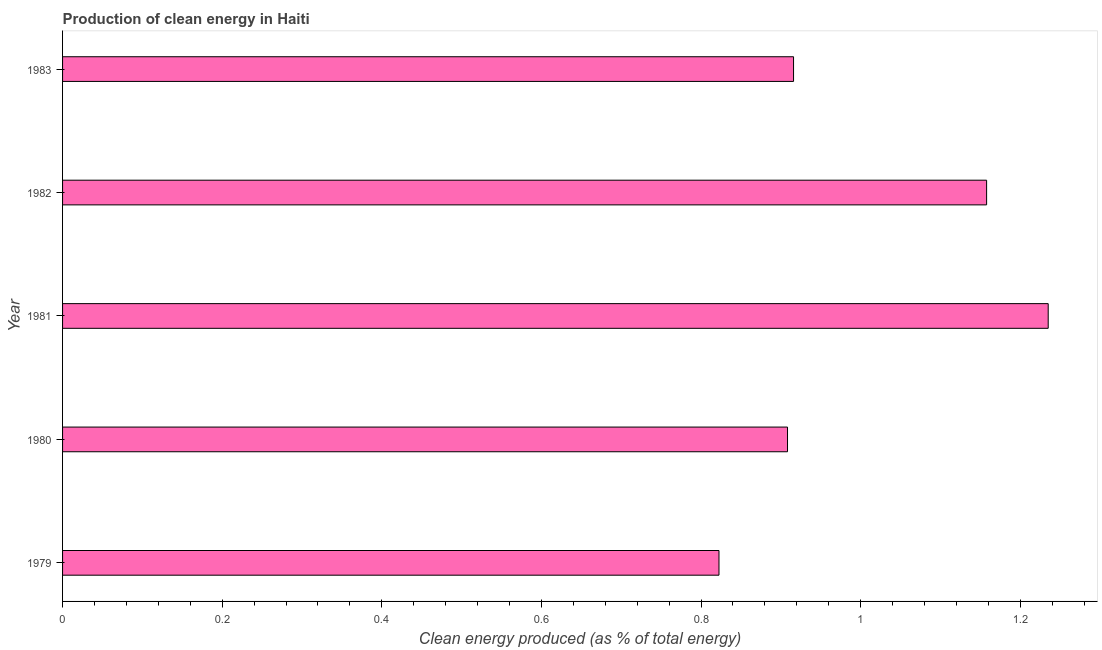What is the title of the graph?
Offer a very short reply. Production of clean energy in Haiti. What is the label or title of the X-axis?
Make the answer very short. Clean energy produced (as % of total energy). What is the production of clean energy in 1983?
Ensure brevity in your answer.  0.92. Across all years, what is the maximum production of clean energy?
Your answer should be compact. 1.23. Across all years, what is the minimum production of clean energy?
Ensure brevity in your answer.  0.82. In which year was the production of clean energy maximum?
Give a very brief answer. 1981. In which year was the production of clean energy minimum?
Provide a succinct answer. 1979. What is the sum of the production of clean energy?
Offer a terse response. 5.04. What is the difference between the production of clean energy in 1981 and 1983?
Your answer should be compact. 0.32. What is the average production of clean energy per year?
Your answer should be compact. 1.01. What is the median production of clean energy?
Offer a very short reply. 0.92. In how many years, is the production of clean energy greater than 0.88 %?
Your response must be concise. 4. What is the ratio of the production of clean energy in 1981 to that in 1982?
Provide a short and direct response. 1.07. Is the difference between the production of clean energy in 1981 and 1982 greater than the difference between any two years?
Keep it short and to the point. No. What is the difference between the highest and the second highest production of clean energy?
Your response must be concise. 0.08. What is the difference between the highest and the lowest production of clean energy?
Your answer should be compact. 0.41. How many bars are there?
Ensure brevity in your answer.  5. How many years are there in the graph?
Offer a terse response. 5. Are the values on the major ticks of X-axis written in scientific E-notation?
Your answer should be compact. No. What is the Clean energy produced (as % of total energy) in 1979?
Provide a short and direct response. 0.82. What is the Clean energy produced (as % of total energy) of 1980?
Your response must be concise. 0.91. What is the Clean energy produced (as % of total energy) in 1981?
Make the answer very short. 1.23. What is the Clean energy produced (as % of total energy) of 1982?
Give a very brief answer. 1.16. What is the Clean energy produced (as % of total energy) in 1983?
Your answer should be compact. 0.92. What is the difference between the Clean energy produced (as % of total energy) in 1979 and 1980?
Provide a short and direct response. -0.09. What is the difference between the Clean energy produced (as % of total energy) in 1979 and 1981?
Provide a succinct answer. -0.41. What is the difference between the Clean energy produced (as % of total energy) in 1979 and 1982?
Your answer should be compact. -0.34. What is the difference between the Clean energy produced (as % of total energy) in 1979 and 1983?
Offer a terse response. -0.09. What is the difference between the Clean energy produced (as % of total energy) in 1980 and 1981?
Offer a terse response. -0.33. What is the difference between the Clean energy produced (as % of total energy) in 1980 and 1982?
Provide a succinct answer. -0.25. What is the difference between the Clean energy produced (as % of total energy) in 1980 and 1983?
Your answer should be compact. -0.01. What is the difference between the Clean energy produced (as % of total energy) in 1981 and 1982?
Offer a very short reply. 0.08. What is the difference between the Clean energy produced (as % of total energy) in 1981 and 1983?
Offer a very short reply. 0.32. What is the difference between the Clean energy produced (as % of total energy) in 1982 and 1983?
Your answer should be very brief. 0.24. What is the ratio of the Clean energy produced (as % of total energy) in 1979 to that in 1980?
Provide a succinct answer. 0.91. What is the ratio of the Clean energy produced (as % of total energy) in 1979 to that in 1981?
Provide a succinct answer. 0.67. What is the ratio of the Clean energy produced (as % of total energy) in 1979 to that in 1982?
Offer a very short reply. 0.71. What is the ratio of the Clean energy produced (as % of total energy) in 1979 to that in 1983?
Make the answer very short. 0.9. What is the ratio of the Clean energy produced (as % of total energy) in 1980 to that in 1981?
Make the answer very short. 0.74. What is the ratio of the Clean energy produced (as % of total energy) in 1980 to that in 1982?
Give a very brief answer. 0.79. What is the ratio of the Clean energy produced (as % of total energy) in 1980 to that in 1983?
Offer a very short reply. 0.99. What is the ratio of the Clean energy produced (as % of total energy) in 1981 to that in 1982?
Your answer should be compact. 1.07. What is the ratio of the Clean energy produced (as % of total energy) in 1981 to that in 1983?
Offer a terse response. 1.35. What is the ratio of the Clean energy produced (as % of total energy) in 1982 to that in 1983?
Offer a very short reply. 1.26. 